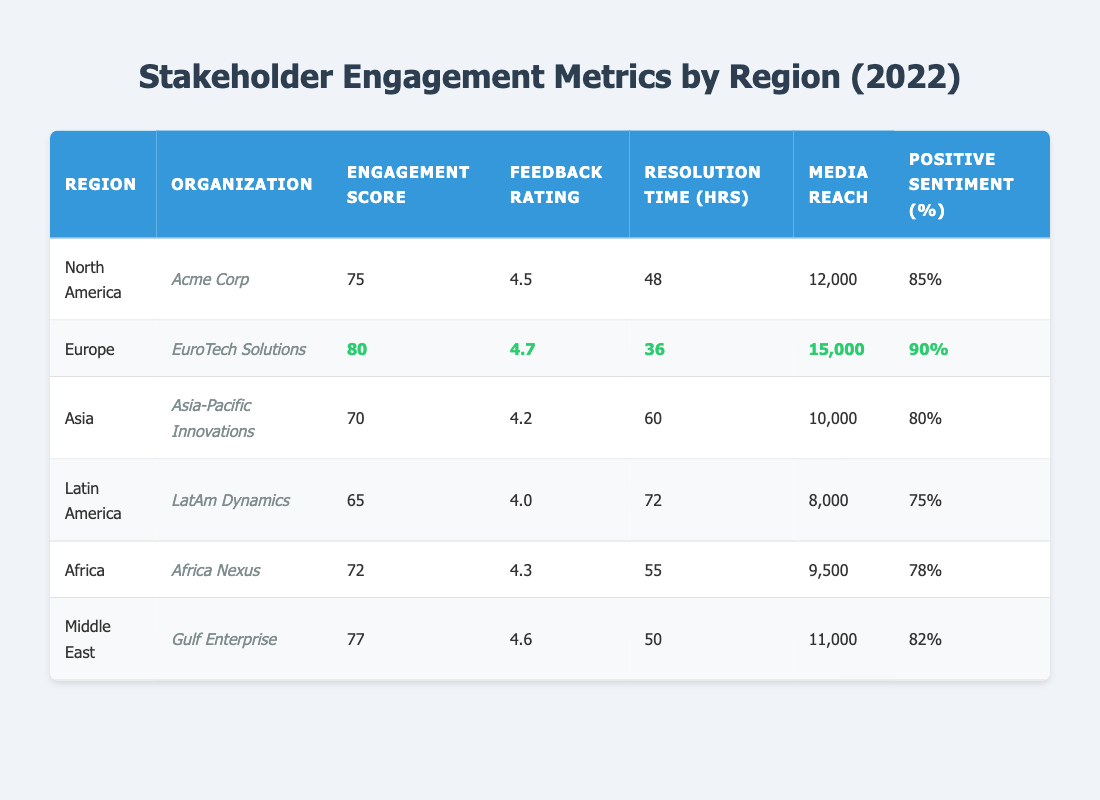What is the engagement score of EuroTech Solutions? The engagement score for EuroTech Solutions is highlighted in the table cell corresponding to the Europe region, which shows a score of 80.
Answer: 80 Which region has the highest positive sentiment percentage? The highest positive sentiment percentage of 90% is found in the Europe region next to EuroTech Solutions, which is highlighted in the table.
Answer: Europe What is the resolution time for Asia-Pacific Innovations? The resolution time for Asia-Pacific Innovations is located in the table under the Asia row, listed as 60 hours.
Answer: 60 What is the average engagement score of regions other than Europe? The engagement scores for the other regions are 75 (North America), 70 (Asia), 65 (Latin America), 72 (Africa), and 77 (Middle East). Adding these (75 + 70 + 65 + 72 + 77) gives 359, and dividing by 5 gives an average of 71.8.
Answer: 71.8 Is the feedback rating for Acme Corp higher than that for LatAm Dynamics? The feedback rating for Acme Corp is 4.5, and the rating for LatAm Dynamics is 4.0, so 4.5 > 4.0 is true.
Answer: Yes What is the media reach for Africa Nexus compared to Asia-Pacific Innovations? The media reach for Africa Nexus is 9,500, while for Asia-Pacific Innovations it is 10,000. Since 9,500 is less than 10,000, Africa Nexus has a lower media reach than Asia-Pacific Innovations.
Answer: Lower Which organization had the longest resolution time? By examining the resolution times provided in the table, LatAm Dynamics has the longest resolution time at 72 hours, as indicated in its row.
Answer: LatAm Dynamics Calculate the difference in positive sentiment between the regions with the highest and lowest scores. The highest positive sentiment is 90% (Europe) and the lowest is 75% (Latin America). The difference is calculated as 90 - 75 = 15.
Answer: 15 Which region has the highest feedback rating? The highest feedback rating is for EuroTech Solutions, which is at 4.7 according to the Europe row in the table.
Answer: Europe Are there any regions with an engagement score below 70? Yes, both Asia (70) and Latin America (65) show engagement scores below 70 according to their respective rows.
Answer: Yes 